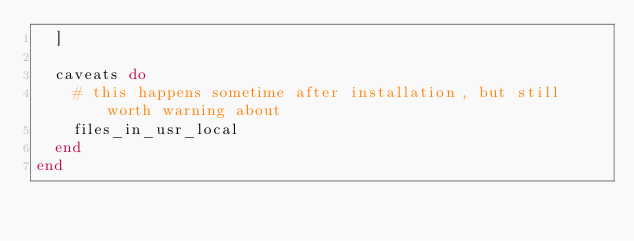Convert code to text. <code><loc_0><loc_0><loc_500><loc_500><_Ruby_>  ]

  caveats do
    # this happens sometime after installation, but still worth warning about
    files_in_usr_local
  end
end
</code> 